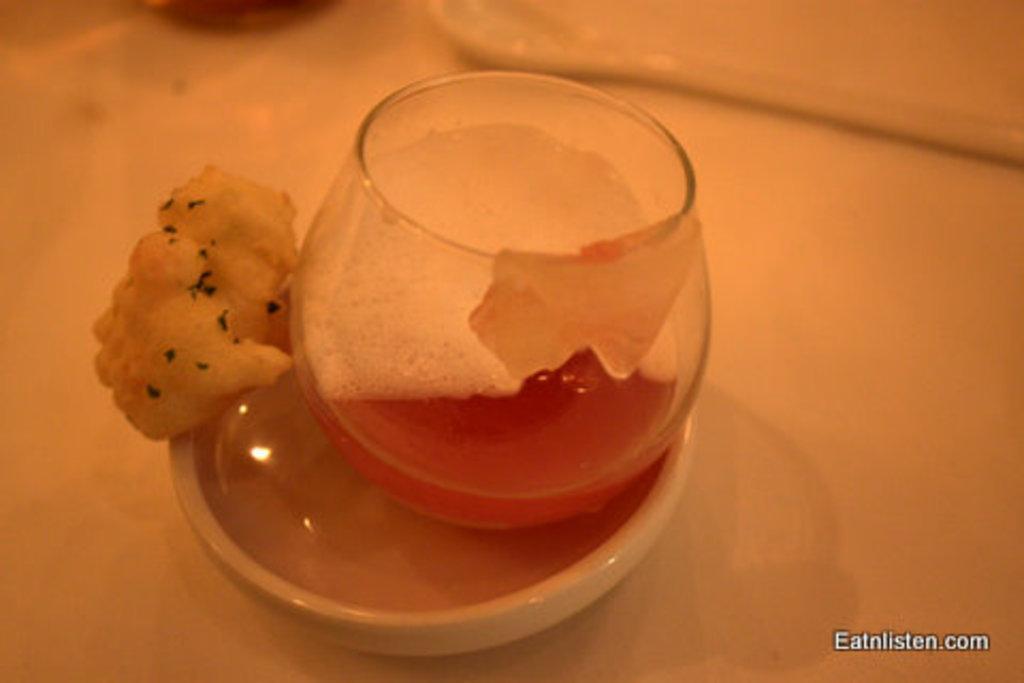Can you describe this image briefly? In this picture we can see glass, bowl, food and objects on the platform. In the bottom right side of the image we can see text. 